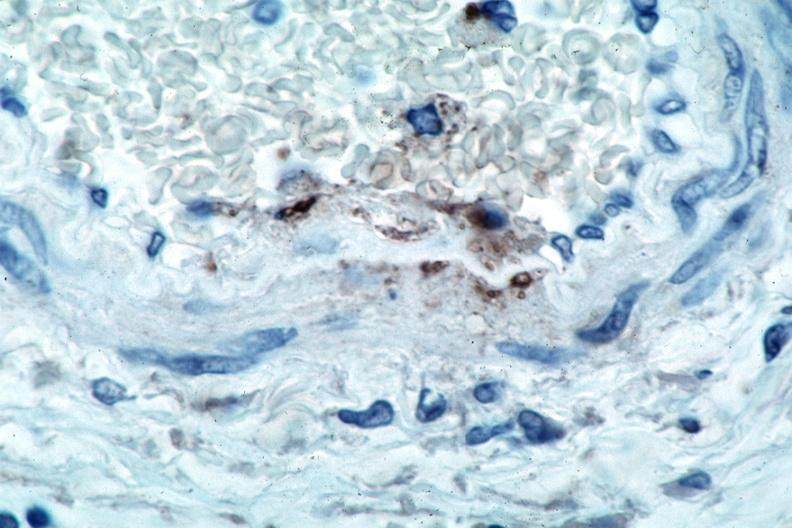s cranial artery present?
Answer the question using a single word or phrase. No 